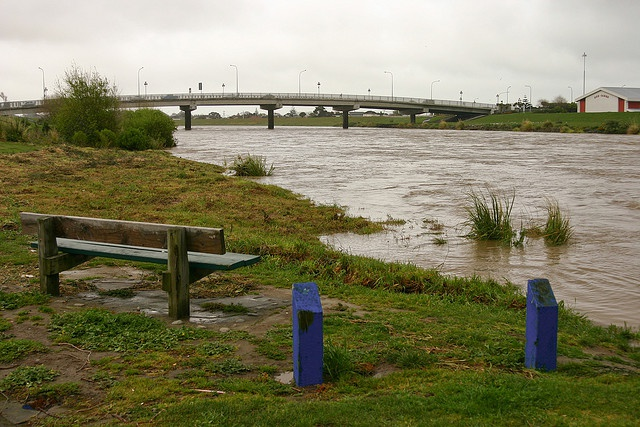Describe the objects in this image and their specific colors. I can see bench in lightgray, black, darkgreen, and gray tones, car in lightgray, gray, and darkgray tones, and car in gray and lightgray tones in this image. 